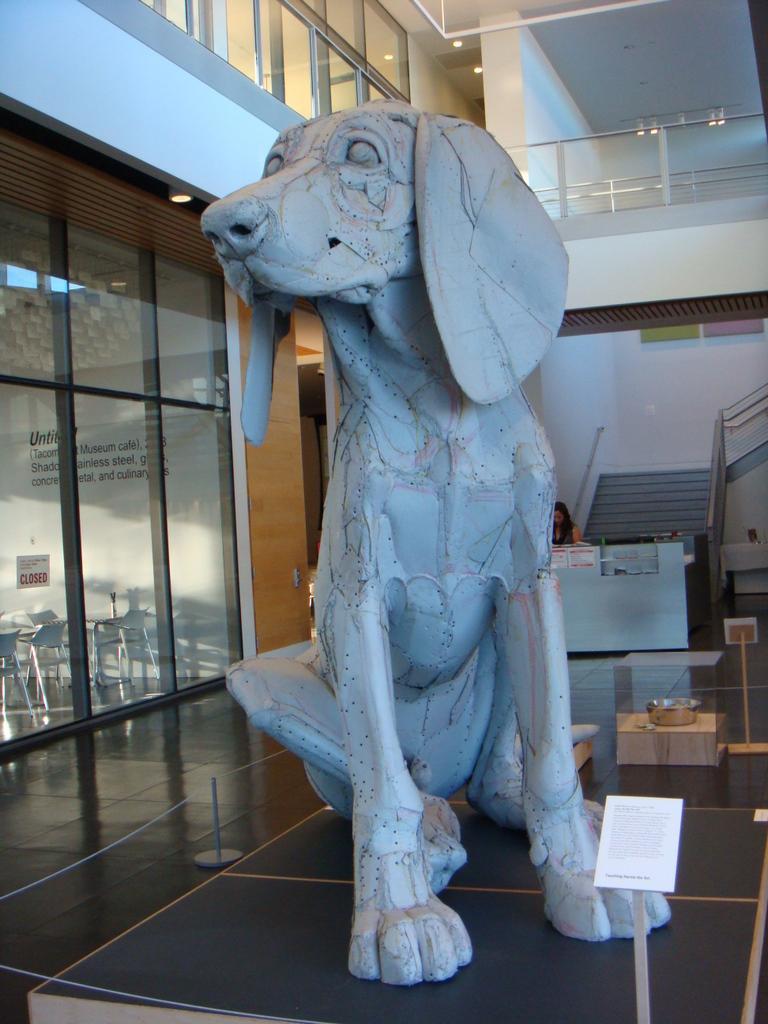How would you summarize this image in a sentence or two? In this picture we can see a statue on a platform and in the background we can see a wall,rods,woman. 